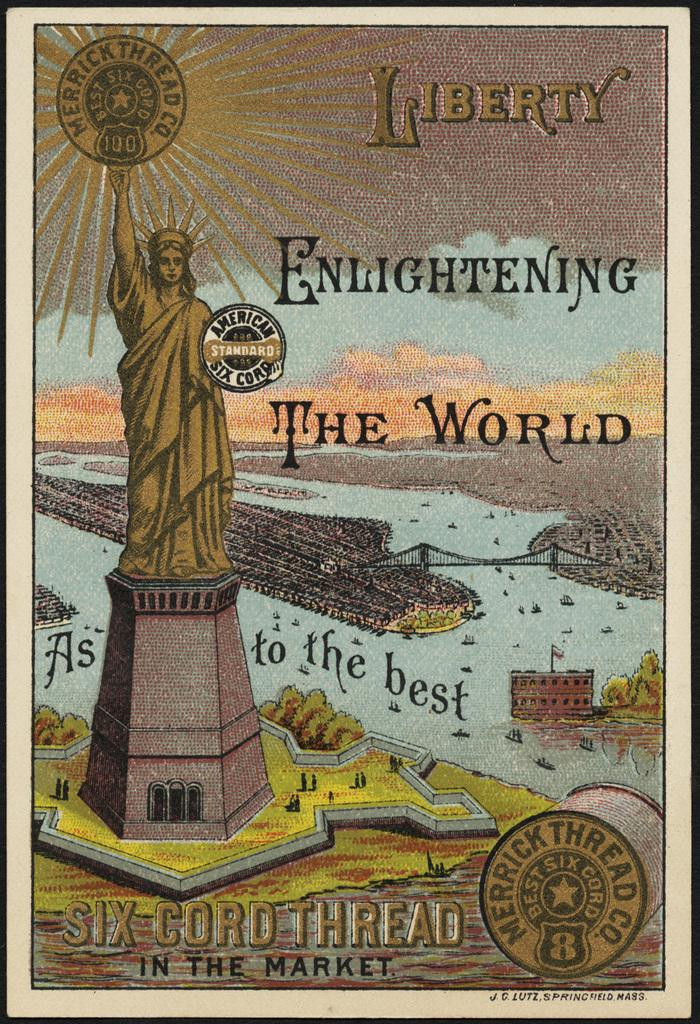<image>
Give a short and clear explanation of the subsequent image. The poster for Six Cord Thread features the Statue of Liberty and the phrase, "Liberty Enlightening the World." 